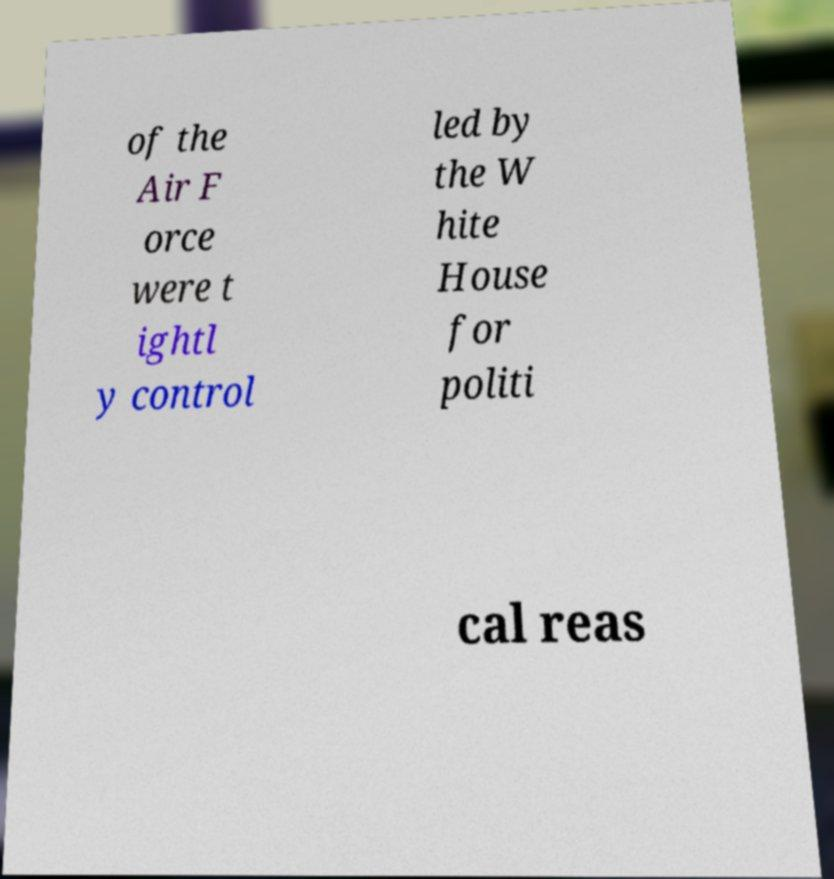Can you accurately transcribe the text from the provided image for me? of the Air F orce were t ightl y control led by the W hite House for politi cal reas 